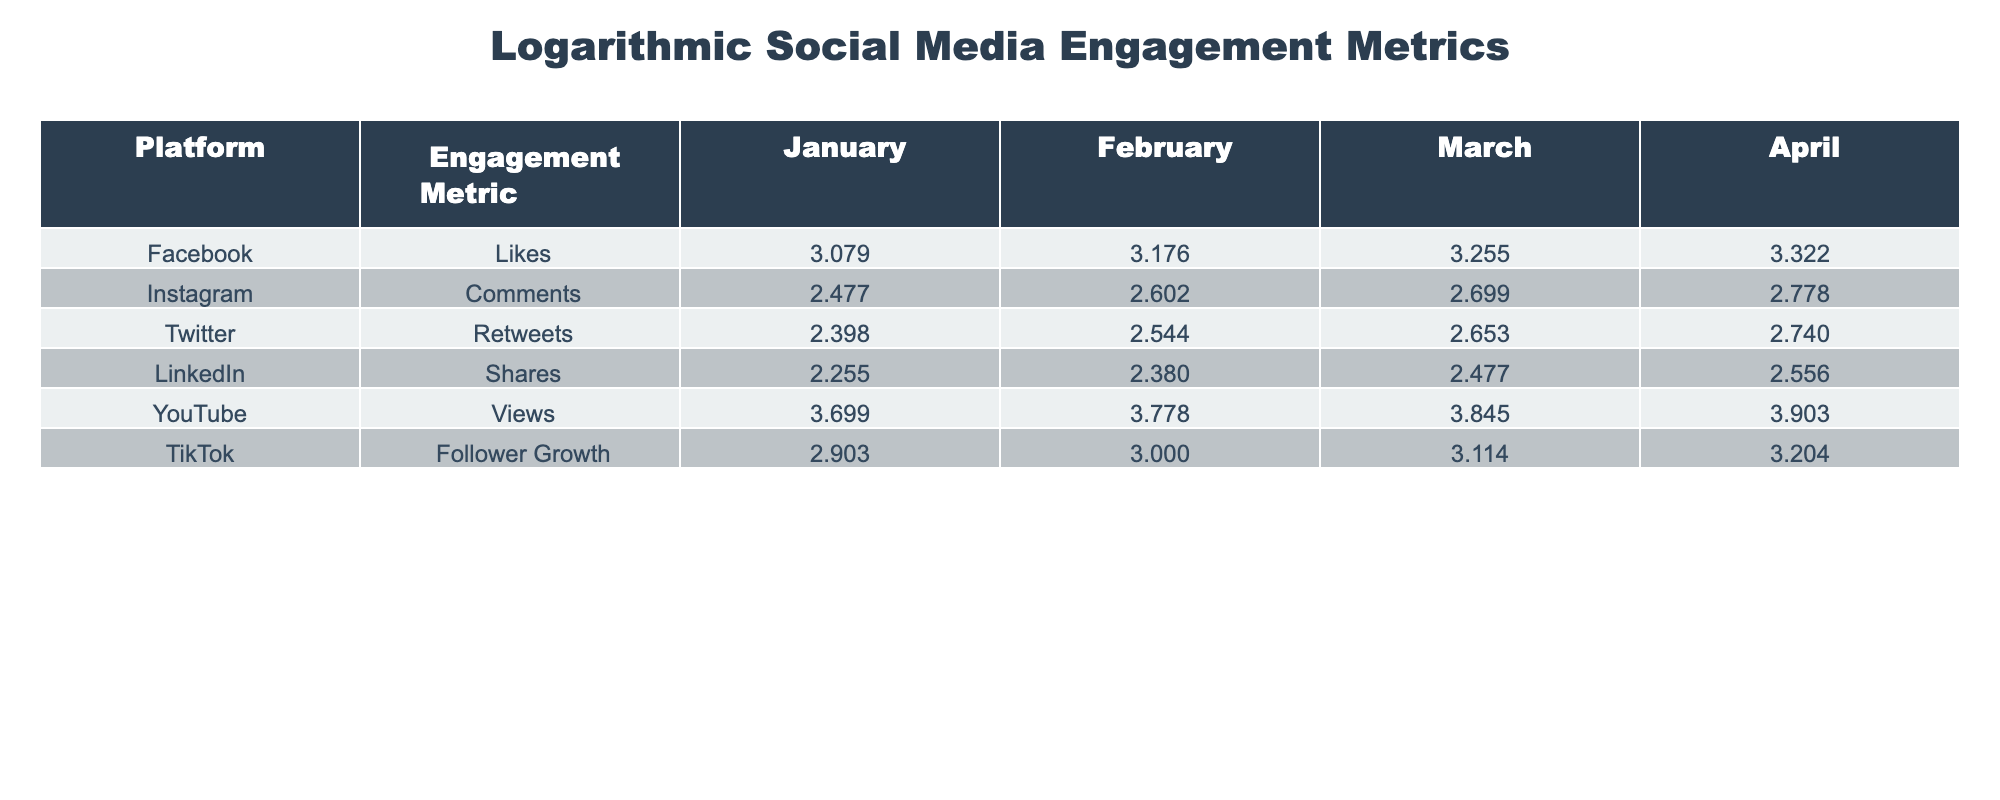What was the highest engagement metric in March? By looking at the values in the March column across all platforms, the highest value is 7.000 from YouTube Views.
Answer: 7000 What is the logarithmic value of Likes on Facebook in February? In the table, the value for Likes on Facebook in February is 1500. The logarithmic value is calculated as log10(1500), which approximately equals 3.176.
Answer: 3.176 Is there an increase in the number of Retweets on Twitter from January to April? The number of Retweets increased from 250 in January to 550 in April, indicating growth.
Answer: Yes What is the average logarithmic value of Comments on Instagram from January to April? The values for Comments are 300, 400, 500, and 600. First, convert them to logarithm (approx. 2.477 for 300, 2.602 for 400, 2.699 for 500, and 2.778 for 600). Sum: 2.477 + 2.602 + 2.699 + 2.778 = 10.556, then divide by 4 to find the average which is 10.556 / 4 = 2.639.
Answer: 2.639 Which platform had the lowest logarithmic value for Shares in January? The value for Shares on LinkedIn in January is 180, which when transformed logarithmically is log10(180) = approximately 2.255. Cross-referencing with other platforms shows this to be the lowest value.
Answer: LinkedIn 